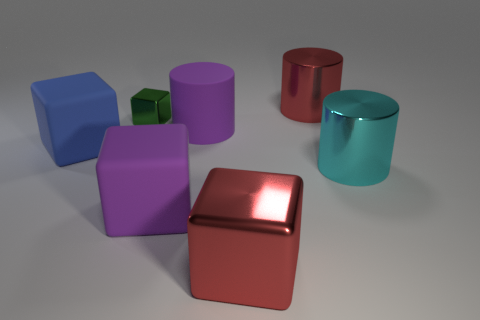Is there any other thing that is the same size as the green block?
Make the answer very short. No. There is another large matte thing that is the same shape as the large blue thing; what color is it?
Keep it short and to the point. Purple. What number of large rubber cubes are the same color as the big rubber cylinder?
Give a very brief answer. 1. How many objects are either large red cylinders that are behind the small thing or tiny gray things?
Your answer should be very brief. 1. How big is the metallic cube that is behind the purple cube?
Your answer should be very brief. Small. Is the number of large cylinders less than the number of shiny objects?
Offer a terse response. Yes. Is the material of the thing that is behind the small metallic object the same as the red thing in front of the blue thing?
Make the answer very short. Yes. What is the shape of the large thing that is to the right of the red thing that is to the right of the big shiny block right of the blue matte cube?
Offer a terse response. Cylinder. What number of large cyan cylinders are made of the same material as the large red block?
Your answer should be very brief. 1. There is a big cylinder behind the purple rubber cylinder; how many small things are behind it?
Your response must be concise. 0. 